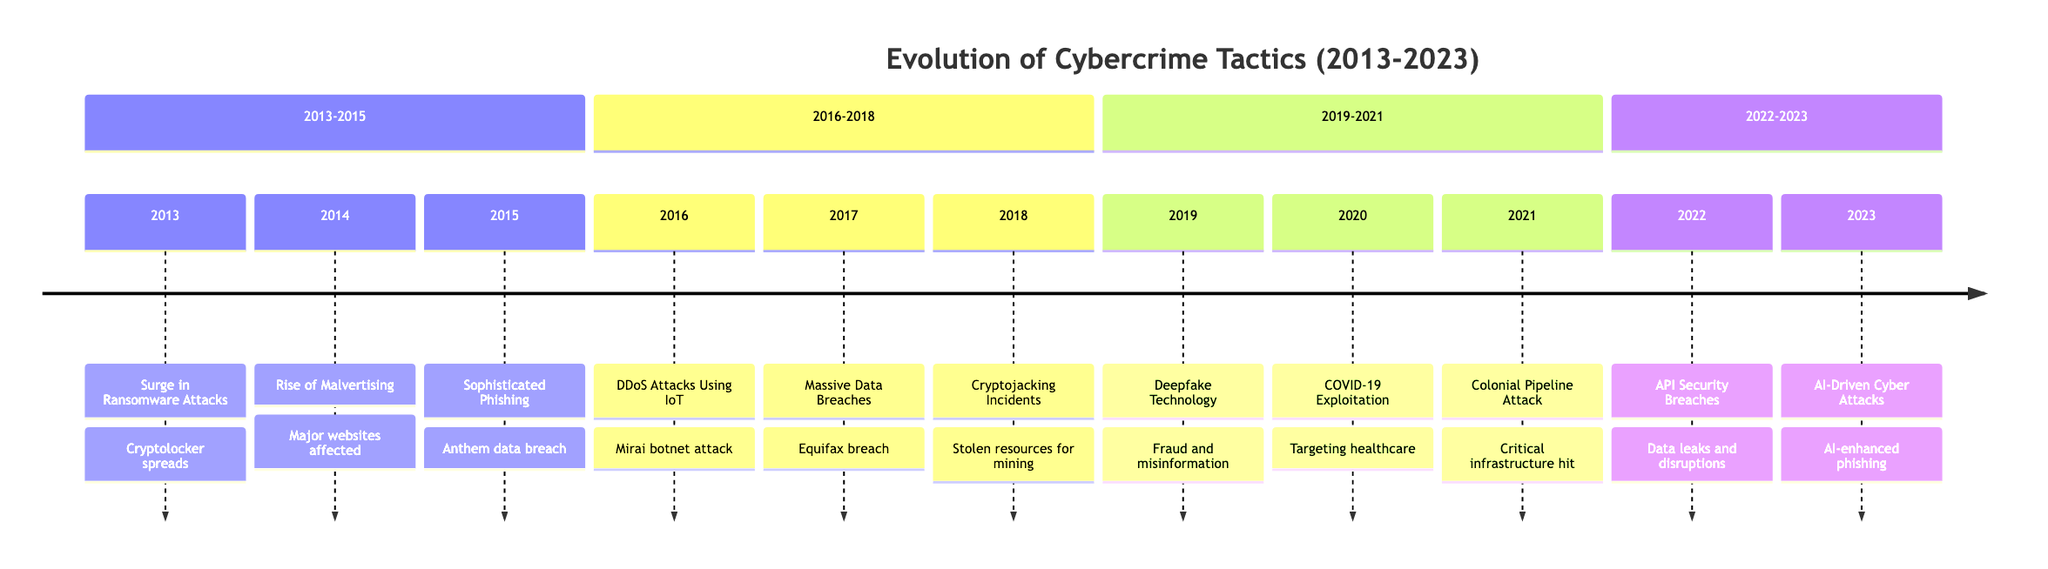What event occurred in 2013? The diagram clearly shows the event for 2013 is "Surge in Ransomware Attacks." This is found at the year 2013 on the timeline.
Answer: Surge in Ransomware Attacks How many events are listed for the year 2016? The diagram displays only one event for the year 2016, which is "DDoS Attacks Using IoT Devices." Counting the events along that year results in just one event.
Answer: 1 Which year saw the introduction of Deepfake Technology? By scanning the timeline, we can find that the entry for Deepfake Technology is listed under the year 2019. Therefore, the answer is determined directly from the timeline's labeling.
Answer: 2019 What significant attack highlighted vulnerabilities in critical infrastructure? The diagram details that the "Colonial Pipeline Ransomware Attack" was the event that highlighted vulnerabilities in critical infrastructure. This is explicitly stated for the year 2021.
Answer: Colonial Pipeline Ransomware Attack In which year did cybercriminals start exploiting the COVID-19 pandemic? The timeline indicates that this exploitation occurred in 2020, marking a significant shift in cybercrime tactics during the pandemic. This can be directly referenced from the event descriptions in that year.
Answer: 2020 What was the major incident involving API Security Breaches? According to the timeline, the entry for year 2022 describes "API Security Breaches," which caused significant data leaks. The event is specifically allocated to that year.
Answer: API Security Breaches Which two years saw incidents of massive data breaches? By referring to the timeline, we observe "Massive Data Breaches" noted for 2017 and "Anthem data breach" under 2015. Both events describe significant data breaches over those respective years.
Answer: 2015, 2017 What tactic saw an increase due to the rise of cryptocurrency? The timeline mentions "Cryptojacking Incidents Increase" as a tactic related to the rise of cryptocurrency, detailing how attackers began to utilize stolen resources for mining. This is evident in the year 2018.
Answer: Cryptojacking Incidents Increase What technological advancement was mentioned in relation to cyber attacks in 2023? The timeline states that "AI-Driven Cyber Attacks" emerged in 2023, indicating a notable advancement in the tools and methods used by cybercriminals. This is directly identifiable on the timeline.
Answer: AI-Driven Cyber Attacks 